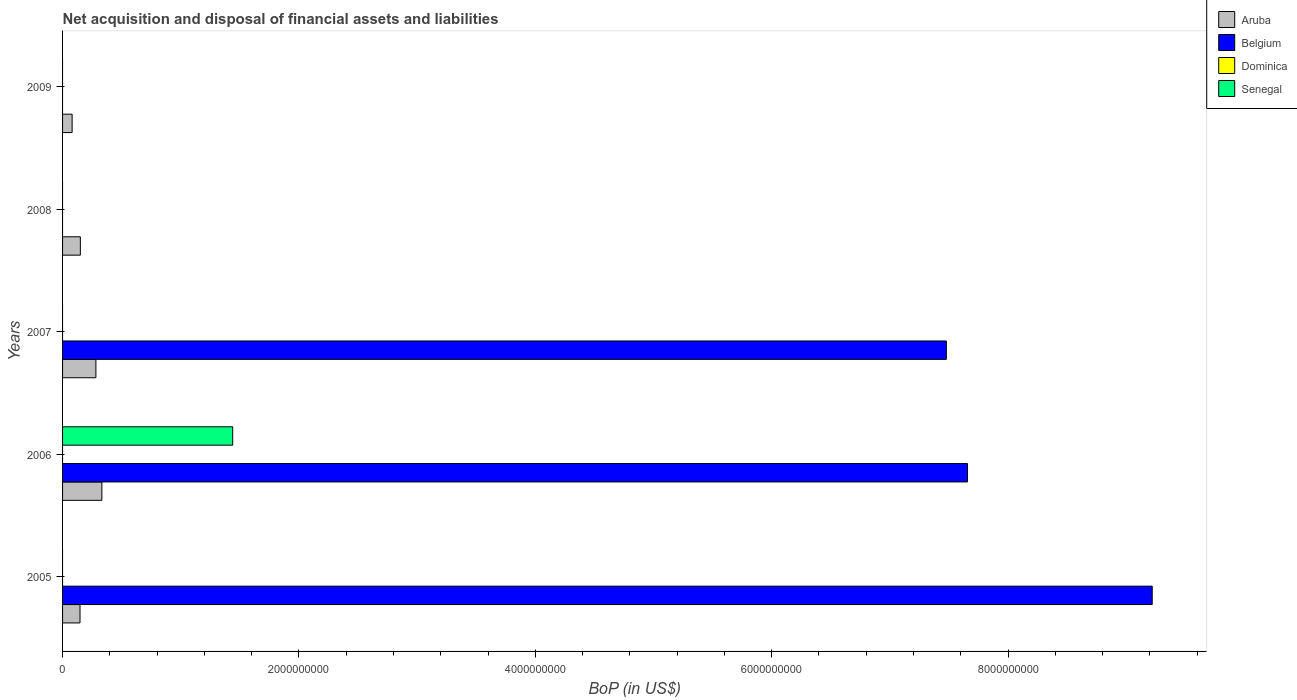How many different coloured bars are there?
Your answer should be compact. 3. Are the number of bars per tick equal to the number of legend labels?
Make the answer very short. No. What is the label of the 1st group of bars from the top?
Your response must be concise. 2009. What is the Balance of Payments in Belgium in 2007?
Offer a terse response. 7.48e+09. Across all years, what is the maximum Balance of Payments in Senegal?
Your answer should be compact. 1.44e+09. Across all years, what is the minimum Balance of Payments in Aruba?
Your answer should be very brief. 8.09e+07. What is the total Balance of Payments in Aruba in the graph?
Ensure brevity in your answer.  9.94e+08. What is the difference between the Balance of Payments in Aruba in 2005 and that in 2008?
Offer a very short reply. -2.90e+06. What is the difference between the Balance of Payments in Senegal in 2008 and the Balance of Payments in Belgium in 2007?
Your response must be concise. -7.48e+09. What is the average Balance of Payments in Senegal per year?
Ensure brevity in your answer.  2.88e+08. In the year 2006, what is the difference between the Balance of Payments in Senegal and Balance of Payments in Aruba?
Your answer should be compact. 1.11e+09. What is the ratio of the Balance of Payments in Aruba in 2008 to that in 2009?
Your answer should be compact. 1.86. What is the difference between the highest and the second highest Balance of Payments in Aruba?
Offer a terse response. 5.04e+07. What is the difference between the highest and the lowest Balance of Payments in Aruba?
Provide a short and direct response. 2.52e+08. In how many years, is the Balance of Payments in Belgium greater than the average Balance of Payments in Belgium taken over all years?
Your answer should be very brief. 3. Is it the case that in every year, the sum of the Balance of Payments in Aruba and Balance of Payments in Senegal is greater than the Balance of Payments in Dominica?
Ensure brevity in your answer.  Yes. Are all the bars in the graph horizontal?
Keep it short and to the point. Yes. Does the graph contain any zero values?
Your response must be concise. Yes. Where does the legend appear in the graph?
Your answer should be compact. Top right. How many legend labels are there?
Offer a very short reply. 4. How are the legend labels stacked?
Provide a succinct answer. Vertical. What is the title of the graph?
Provide a succinct answer. Net acquisition and disposal of financial assets and liabilities. What is the label or title of the X-axis?
Provide a succinct answer. BoP (in US$). What is the label or title of the Y-axis?
Ensure brevity in your answer.  Years. What is the BoP (in US$) in Aruba in 2005?
Ensure brevity in your answer.  1.48e+08. What is the BoP (in US$) in Belgium in 2005?
Give a very brief answer. 9.22e+09. What is the BoP (in US$) of Aruba in 2006?
Keep it short and to the point. 3.33e+08. What is the BoP (in US$) of Belgium in 2006?
Provide a short and direct response. 7.66e+09. What is the BoP (in US$) of Dominica in 2006?
Provide a succinct answer. 0. What is the BoP (in US$) in Senegal in 2006?
Your answer should be very brief. 1.44e+09. What is the BoP (in US$) in Aruba in 2007?
Provide a succinct answer. 2.82e+08. What is the BoP (in US$) of Belgium in 2007?
Your response must be concise. 7.48e+09. What is the BoP (in US$) in Aruba in 2008?
Your response must be concise. 1.51e+08. What is the BoP (in US$) in Dominica in 2008?
Your response must be concise. 0. What is the BoP (in US$) in Aruba in 2009?
Your answer should be very brief. 8.09e+07. What is the BoP (in US$) of Dominica in 2009?
Ensure brevity in your answer.  0. Across all years, what is the maximum BoP (in US$) in Aruba?
Your answer should be very brief. 3.33e+08. Across all years, what is the maximum BoP (in US$) of Belgium?
Your answer should be very brief. 9.22e+09. Across all years, what is the maximum BoP (in US$) in Senegal?
Give a very brief answer. 1.44e+09. Across all years, what is the minimum BoP (in US$) of Aruba?
Offer a very short reply. 8.09e+07. Across all years, what is the minimum BoP (in US$) of Senegal?
Your response must be concise. 0. What is the total BoP (in US$) in Aruba in the graph?
Ensure brevity in your answer.  9.94e+08. What is the total BoP (in US$) of Belgium in the graph?
Provide a succinct answer. 2.44e+1. What is the total BoP (in US$) in Dominica in the graph?
Provide a short and direct response. 0. What is the total BoP (in US$) in Senegal in the graph?
Your answer should be very brief. 1.44e+09. What is the difference between the BoP (in US$) of Aruba in 2005 and that in 2006?
Ensure brevity in your answer.  -1.85e+08. What is the difference between the BoP (in US$) in Belgium in 2005 and that in 2006?
Keep it short and to the point. 1.56e+09. What is the difference between the BoP (in US$) in Aruba in 2005 and that in 2007?
Offer a very short reply. -1.34e+08. What is the difference between the BoP (in US$) of Belgium in 2005 and that in 2007?
Give a very brief answer. 1.74e+09. What is the difference between the BoP (in US$) of Aruba in 2005 and that in 2008?
Ensure brevity in your answer.  -2.90e+06. What is the difference between the BoP (in US$) in Aruba in 2005 and that in 2009?
Offer a terse response. 6.68e+07. What is the difference between the BoP (in US$) of Aruba in 2006 and that in 2007?
Provide a short and direct response. 5.04e+07. What is the difference between the BoP (in US$) in Belgium in 2006 and that in 2007?
Ensure brevity in your answer.  1.79e+08. What is the difference between the BoP (in US$) of Aruba in 2006 and that in 2008?
Your answer should be very brief. 1.82e+08. What is the difference between the BoP (in US$) of Aruba in 2006 and that in 2009?
Your response must be concise. 2.52e+08. What is the difference between the BoP (in US$) of Aruba in 2007 and that in 2008?
Your response must be concise. 1.32e+08. What is the difference between the BoP (in US$) in Aruba in 2007 and that in 2009?
Keep it short and to the point. 2.01e+08. What is the difference between the BoP (in US$) in Aruba in 2008 and that in 2009?
Offer a very short reply. 6.97e+07. What is the difference between the BoP (in US$) in Aruba in 2005 and the BoP (in US$) in Belgium in 2006?
Make the answer very short. -7.51e+09. What is the difference between the BoP (in US$) of Aruba in 2005 and the BoP (in US$) of Senegal in 2006?
Offer a very short reply. -1.29e+09. What is the difference between the BoP (in US$) of Belgium in 2005 and the BoP (in US$) of Senegal in 2006?
Your answer should be very brief. 7.78e+09. What is the difference between the BoP (in US$) in Aruba in 2005 and the BoP (in US$) in Belgium in 2007?
Offer a very short reply. -7.33e+09. What is the difference between the BoP (in US$) in Aruba in 2006 and the BoP (in US$) in Belgium in 2007?
Keep it short and to the point. -7.15e+09. What is the average BoP (in US$) in Aruba per year?
Offer a very short reply. 1.99e+08. What is the average BoP (in US$) in Belgium per year?
Keep it short and to the point. 4.87e+09. What is the average BoP (in US$) in Dominica per year?
Make the answer very short. 0. What is the average BoP (in US$) of Senegal per year?
Your answer should be very brief. 2.88e+08. In the year 2005, what is the difference between the BoP (in US$) in Aruba and BoP (in US$) in Belgium?
Offer a very short reply. -9.07e+09. In the year 2006, what is the difference between the BoP (in US$) of Aruba and BoP (in US$) of Belgium?
Keep it short and to the point. -7.32e+09. In the year 2006, what is the difference between the BoP (in US$) of Aruba and BoP (in US$) of Senegal?
Your answer should be very brief. -1.11e+09. In the year 2006, what is the difference between the BoP (in US$) in Belgium and BoP (in US$) in Senegal?
Provide a short and direct response. 6.22e+09. In the year 2007, what is the difference between the BoP (in US$) of Aruba and BoP (in US$) of Belgium?
Make the answer very short. -7.20e+09. What is the ratio of the BoP (in US$) of Aruba in 2005 to that in 2006?
Keep it short and to the point. 0.44. What is the ratio of the BoP (in US$) of Belgium in 2005 to that in 2006?
Offer a terse response. 1.2. What is the ratio of the BoP (in US$) in Aruba in 2005 to that in 2007?
Provide a short and direct response. 0.52. What is the ratio of the BoP (in US$) in Belgium in 2005 to that in 2007?
Your answer should be compact. 1.23. What is the ratio of the BoP (in US$) of Aruba in 2005 to that in 2008?
Your answer should be very brief. 0.98. What is the ratio of the BoP (in US$) in Aruba in 2005 to that in 2009?
Offer a terse response. 1.83. What is the ratio of the BoP (in US$) of Aruba in 2006 to that in 2007?
Keep it short and to the point. 1.18. What is the ratio of the BoP (in US$) of Belgium in 2006 to that in 2007?
Provide a succinct answer. 1.02. What is the ratio of the BoP (in US$) in Aruba in 2006 to that in 2008?
Offer a very short reply. 2.21. What is the ratio of the BoP (in US$) in Aruba in 2006 to that in 2009?
Your answer should be compact. 4.11. What is the ratio of the BoP (in US$) in Aruba in 2007 to that in 2008?
Offer a very short reply. 1.87. What is the ratio of the BoP (in US$) of Aruba in 2007 to that in 2009?
Keep it short and to the point. 3.49. What is the ratio of the BoP (in US$) in Aruba in 2008 to that in 2009?
Your answer should be very brief. 1.86. What is the difference between the highest and the second highest BoP (in US$) in Aruba?
Your response must be concise. 5.04e+07. What is the difference between the highest and the second highest BoP (in US$) in Belgium?
Your answer should be very brief. 1.56e+09. What is the difference between the highest and the lowest BoP (in US$) in Aruba?
Your answer should be compact. 2.52e+08. What is the difference between the highest and the lowest BoP (in US$) of Belgium?
Your response must be concise. 9.22e+09. What is the difference between the highest and the lowest BoP (in US$) of Senegal?
Keep it short and to the point. 1.44e+09. 